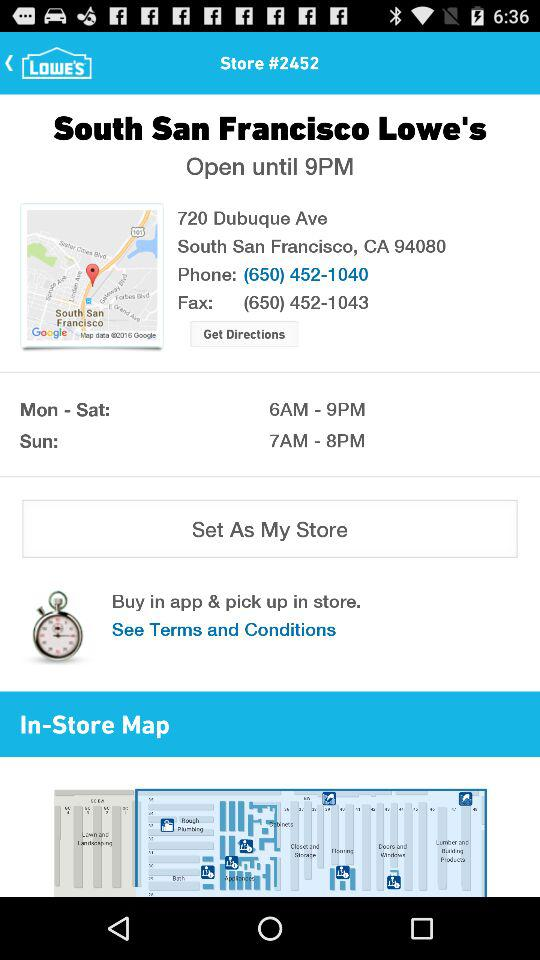What is the opening time on Sunday? The opening time is 7 AM. 